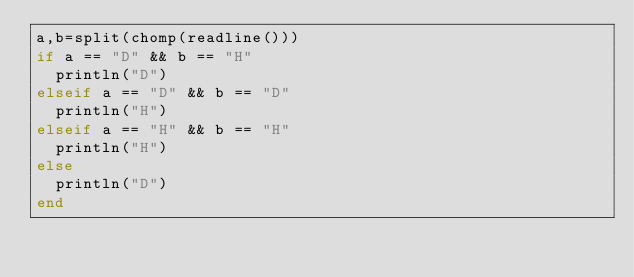<code> <loc_0><loc_0><loc_500><loc_500><_Julia_>a,b=split(chomp(readline()))
if a == "D" && b == "H"
  println("D")
elseif a == "D" && b == "D"
  println("H")
elseif a == "H" && b == "H"
  println("H")
else
  println("D")
end</code> 